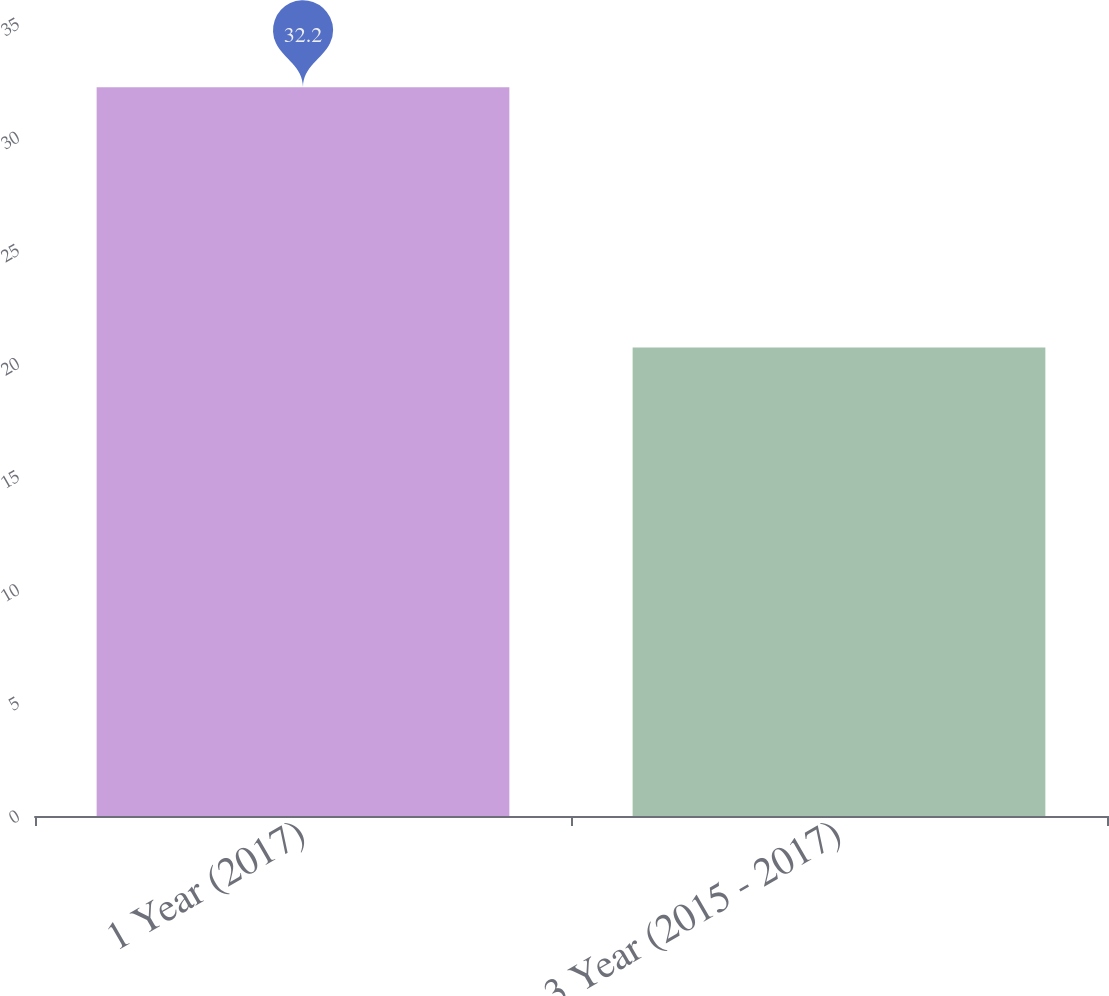Convert chart. <chart><loc_0><loc_0><loc_500><loc_500><bar_chart><fcel>1 Year (2017)<fcel>3 Year (2015 - 2017)<nl><fcel>32.2<fcel>20.7<nl></chart> 